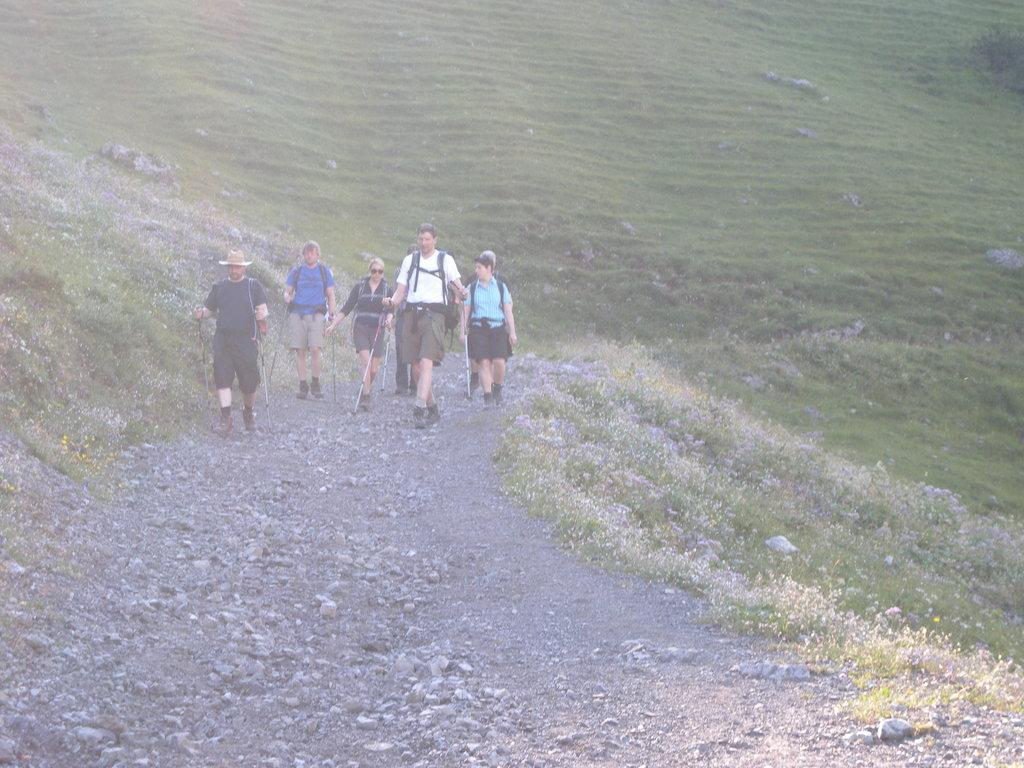What are the people in the image doing? The people in the image are walking on a walkway. What type of vegetation can be seen in the image? Flower plants are visible in the image. What is the color of the grass in the image? Green grass is present in the image. What type of suit is the bridge wearing in the image? There is no bridge or person wearing a suit present in the image. 